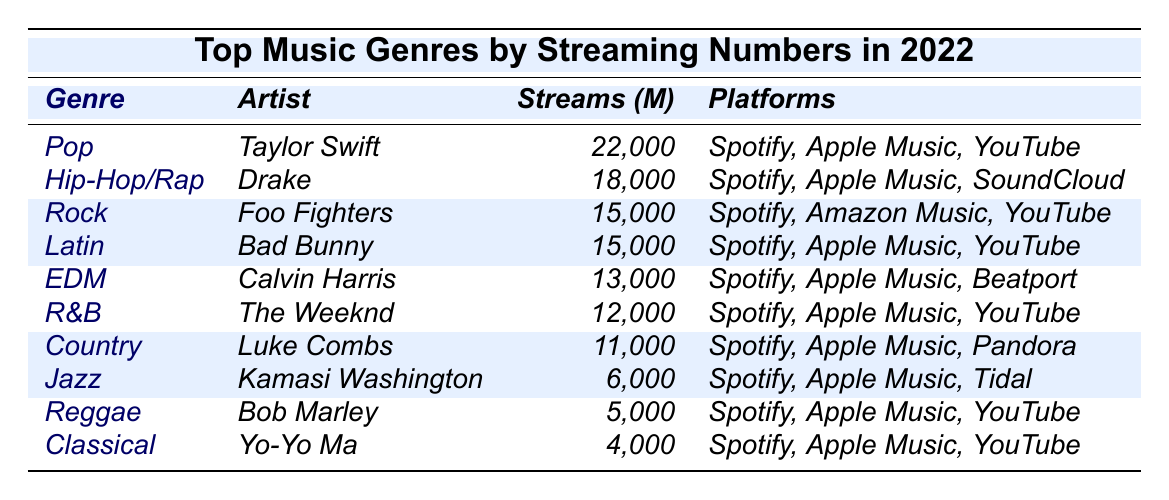What genre topped the streaming numbers in 2022? The table shows that the genre with the highest streaming numbers is 'Pop' with 22,000 million streams.
Answer: Pop Which artist is associated with the Hip-Hop/Rap genre? According to the table, the artist connected to the Hip-Hop/Rap genre is 'Drake'.
Answer: Drake What are the total streaming numbers for Rock and Latin combined? The streaming numbers for Rock is 15,000 million and for Latin is also 15,000 million. Therefore, combined they total 15,000 + 15,000 = 30,000 million.
Answer: 30,000 How many more millions of streams did Pop have compared to Country? Pop has 22,000 million streams and Country has 11,000 million streams. The difference is 22,000 - 11,000 = 11,000 million.
Answer: 11,000 Is the total number of streams for R&B and EDM less than 30,000 million? R&B has 12,000 million and EDM has 13,000 million. Adding them together gives 12,000 + 13,000 = 25,000 million, which is less than 30,000 million. Therefore, the statement is true.
Answer: Yes Which genres are present on all three major streaming platforms? By examining the table, Pop, Hip-Hop/Rap, Rock, Latin, R&B, Country, Jazz, Reggae, and Classical are available on Spotify, Apple Music, and often YouTube, thus confirming their presence across these platforms.
Answer: Pop, Hip-Hop/Rap, Rock, Latin, R&B, Country, Jazz, Reggae, Classical What genre has the least number of streaming numbers? The genre with the lowest streaming numbers is 'Classical', with 4,000 million streams.
Answer: Classical Calculate the average streaming numbers of the genres listed. The total streaming numbers for all genres are 22,000 + 18,000 + 15,000 + 15,000 + 13,000 + 12,000 + 11,000 + 6,000 + 5,000 + 4,000 = 106,000 million. There are 10 genres, so the average is 106,000 / 10 = 10,600 million.
Answer: 10,600 What are the streaming platforms for the artist Kamasi Washington? The table shows that Kamasi Washington is part of the Jazz genre and is available on Spotify, Apple Music, and Tidal.
Answer: Spotify, Apple Music, Tidal How does the streaming number of Reggae compare to EDM? Reggae has 5,000 million streams while EDM has 13,000 million. Therefore, EDM has 13,000 - 5,000 = 8,000 million more streams than Reggae.
Answer: EDM has 8,000 million more than Reggae 